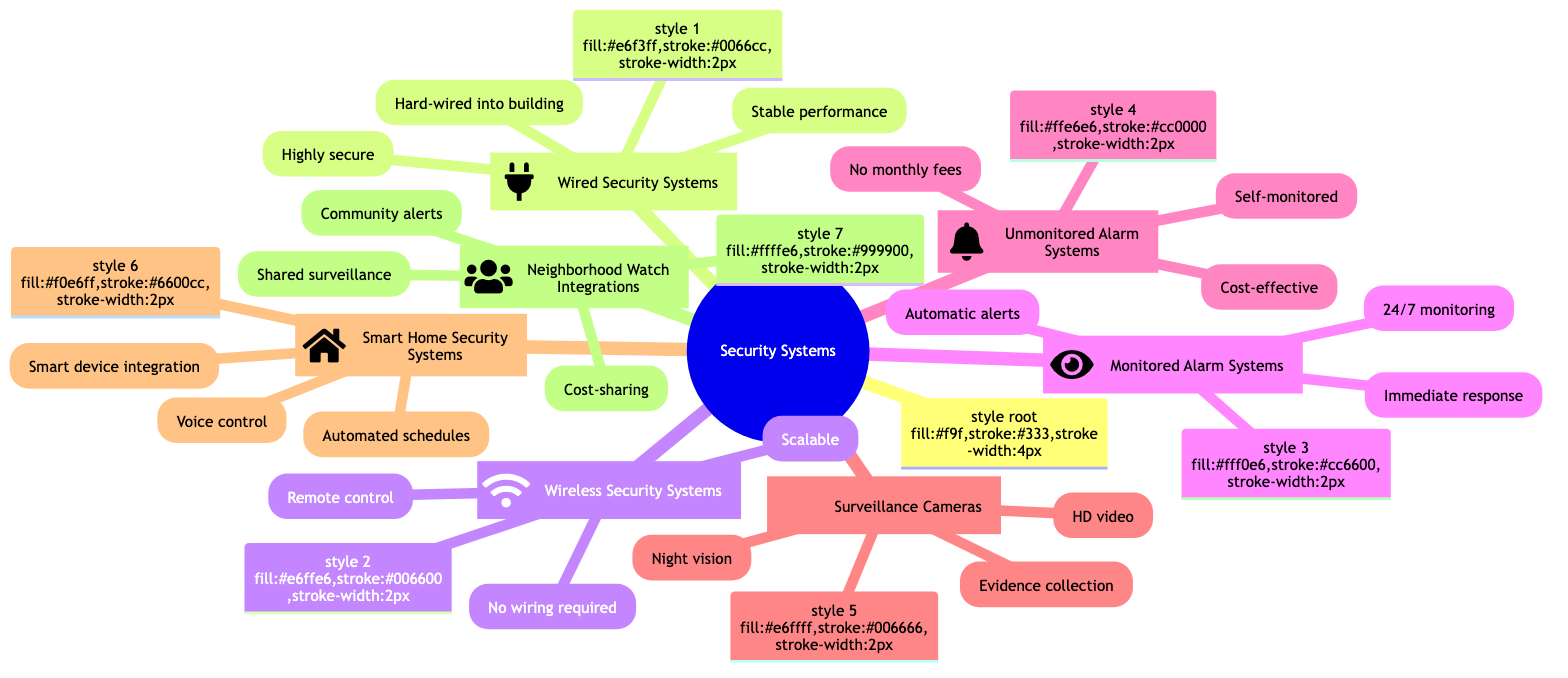What are the features of Wireless Security Systems? The diagram lists three features under Wireless Security Systems: No wiring required, Easy to install and relocate, and Can be controlled remotely via smartphone. Therefore, these are the features that define Wireless Security Systems.
Answer: No wiring required, Easy to install and relocate, Can be controlled remotely via smartphone How many types of security systems are there in the diagram? The diagram contains seven types of security systems, each represented as a distinct node connected to the main root. By counting these nodes, we confirm there are seven types.
Answer: 7 What is a benefit of Monitored Alarm Systems? One of the benefits listed under Monitored Alarm Systems is Immediate response to emergencies. This benefit signifies the quick attention given to situations requiring urgent intervention.
Answer: Immediate response to emergencies Which security system has cost-sharing as a benefit? By examining the benefits listed for each security system, Neighborhood Watch Integrations specifically mentions Cost-sharing among participants as one of its benefits, indicating that community members can share costs.
Answer: Neighborhood Watch Integrations Name a feature of Smart Home Security Systems. The diagram outlines three features of Smart Home Security Systems: Integration with smart home devices, Voice control via assistants like Alexa, and Automated schedules. Therefore, any of these can be identified as a feature, such as Integration with smart home devices.
Answer: Integration with smart home devices Which security system is described as Ideal for large properties? The diagram states that Wired Security Systems are Ideal for large properties. This is a direct mention in the benefits related to this particular type of security system.
Answer: Wired Security Systems What feature is common in Surveillance Cameras for evidence? The main feature related to evidence collection in Surveillance Cameras is that they provide Evidence for investigations. This emphasizes the role of surveillance in supporting legal actions.
Answer: Evidence for investigations 